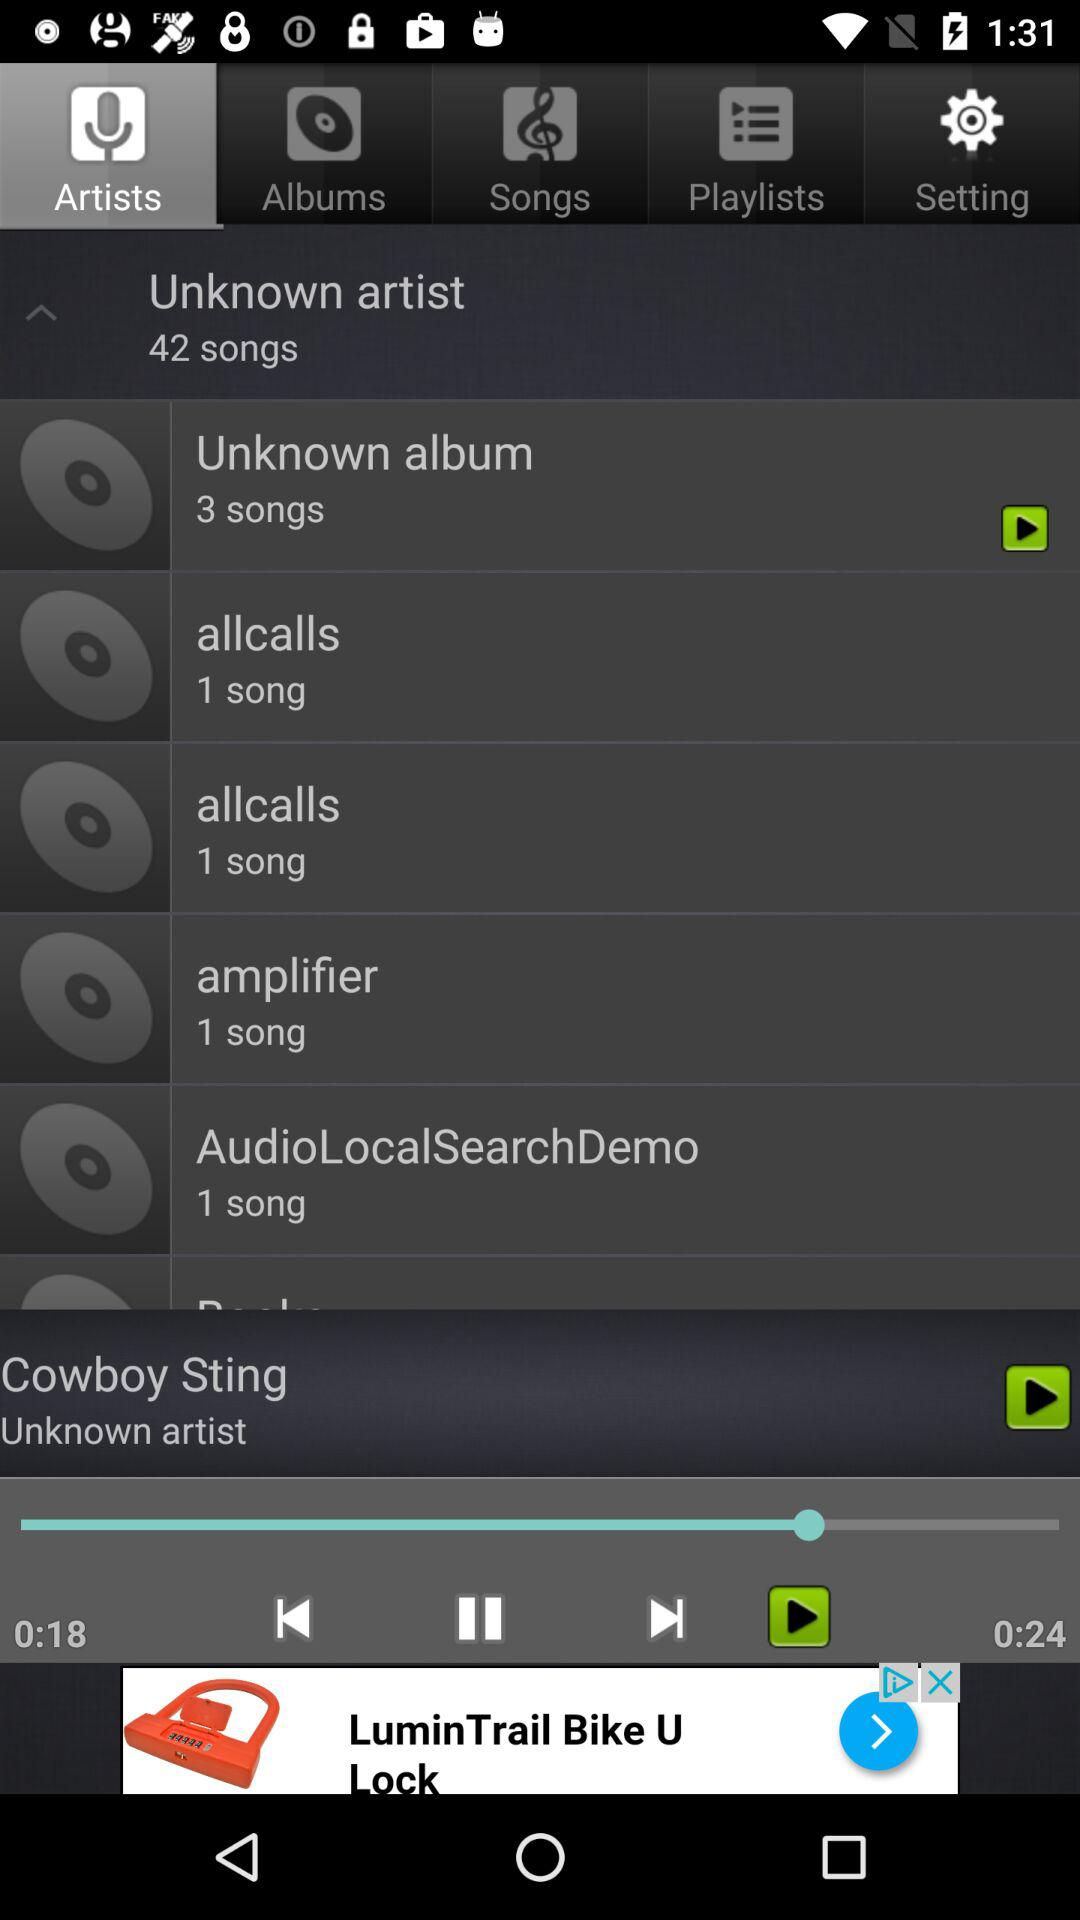Which album has 42 songs? The album that has 42 songs is "Unknown artist". 